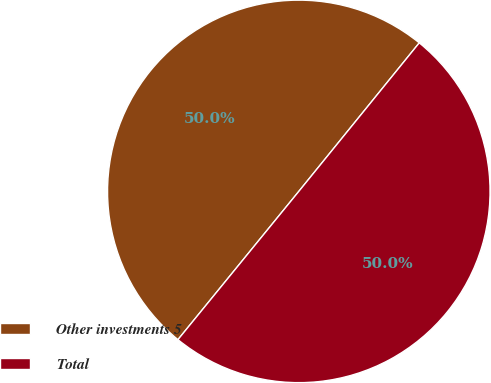Convert chart to OTSL. <chart><loc_0><loc_0><loc_500><loc_500><pie_chart><fcel>Other investments 5<fcel>Total<nl><fcel>49.96%<fcel>50.04%<nl></chart> 